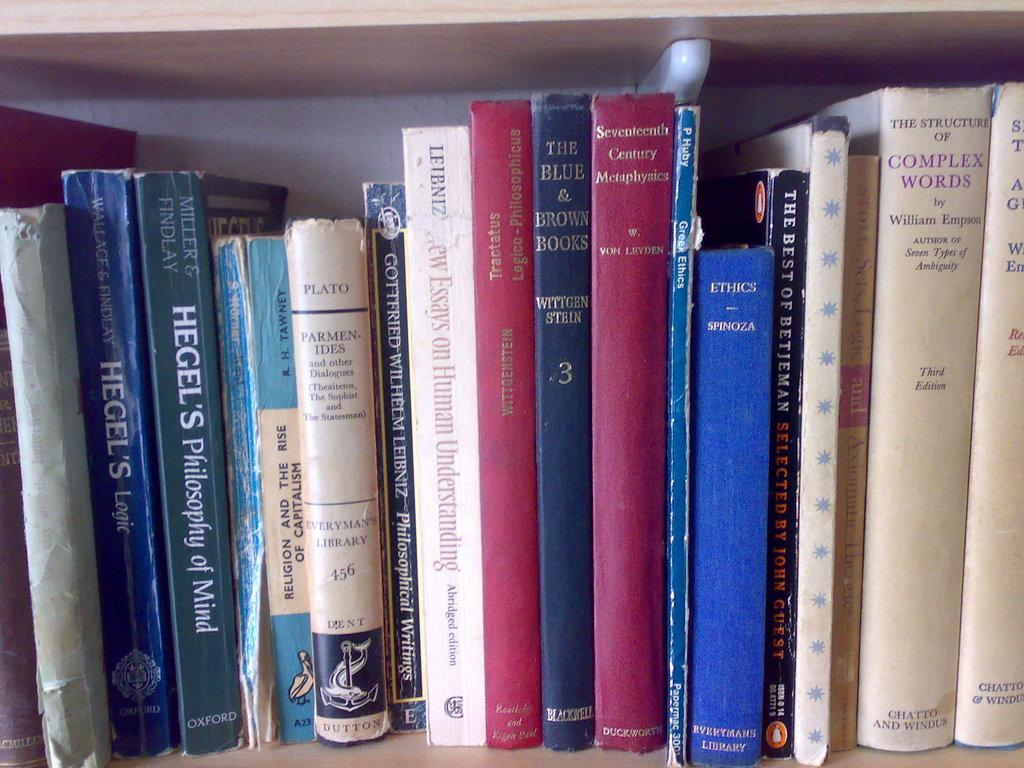<image>
Write a terse but informative summary of the picture. Books on a shelf of various topics including Hegel's Philosophy of Mind 